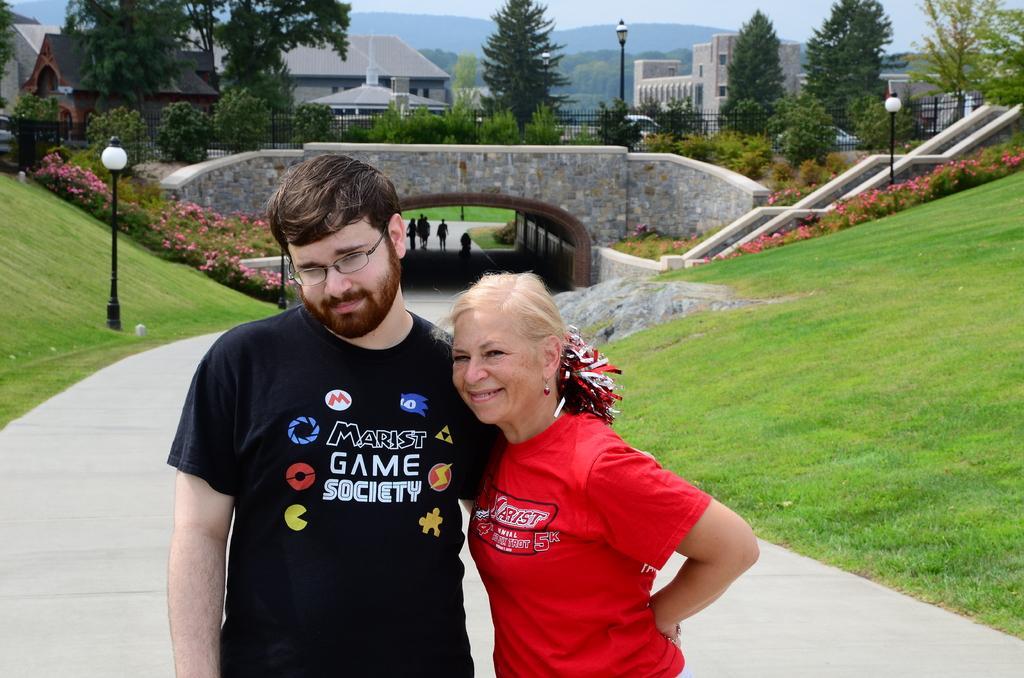Please provide a concise description of this image. In this picture we can see a man wearing a black t-shirt standing in the front,smiling and giving a pose to the camera. Beside there is an old woman wearing a red t-shirt and smiling. Behind we can see green lawn on both sides. In the background we can see arch bridge, shed houses and some trees. 